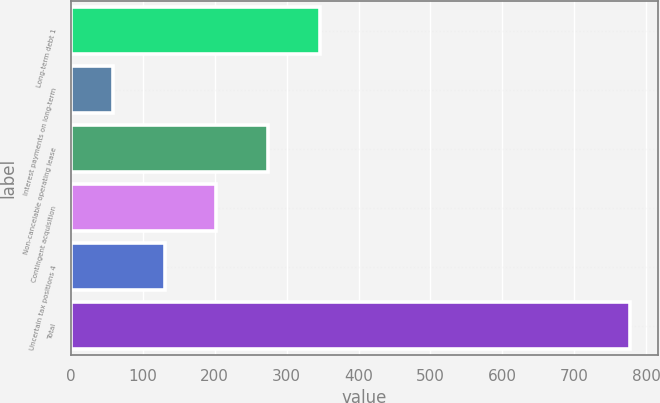<chart> <loc_0><loc_0><loc_500><loc_500><bar_chart><fcel>Long-term debt 1<fcel>Interest payments on long-term<fcel>Non-cancelable operating lease<fcel>Contingent acquisition<fcel>Uncertain tax positions 4<fcel>Total<nl><fcel>346.24<fcel>58.6<fcel>274.33<fcel>202.42<fcel>130.51<fcel>777.7<nl></chart> 